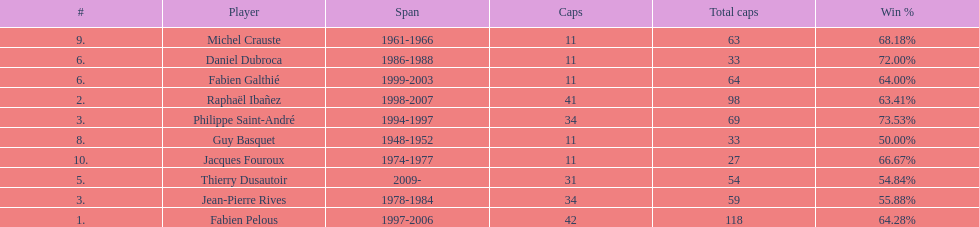How long did fabien pelous serve as captain in the french national rugby team? 9 years. 